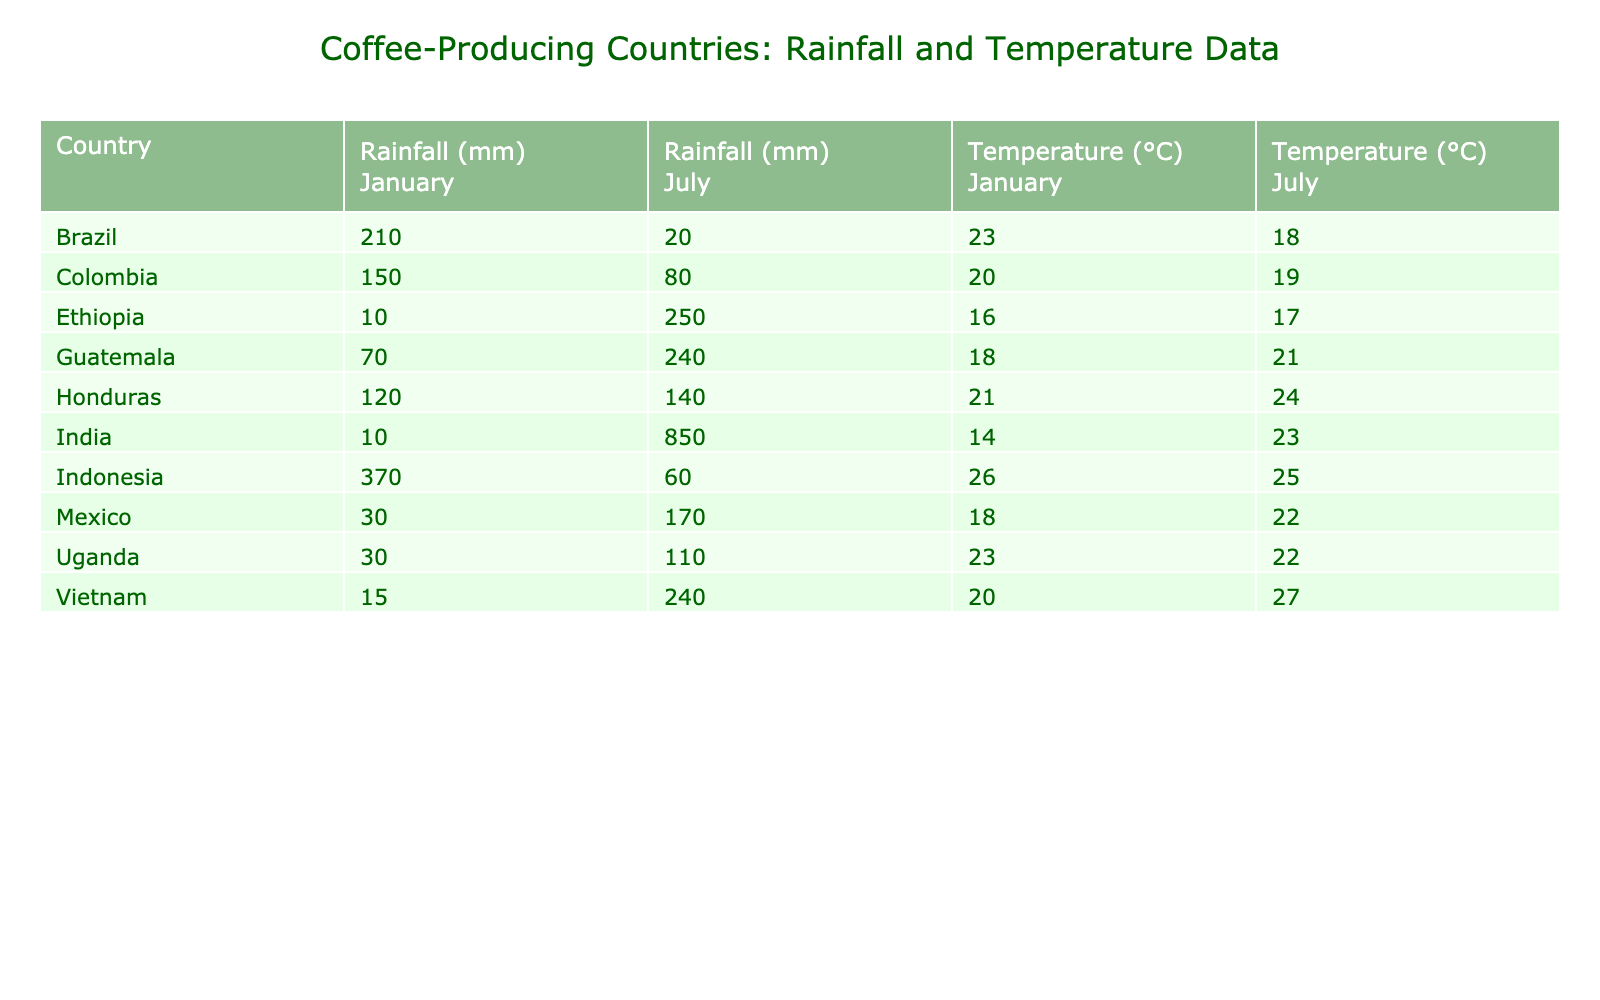What is the highest recorded rainfall in January among the countries listed? By looking at the January rainfall data, Indonesia has the highest value at 370 mm.
Answer: 370 mm Which country has the lowest temperature in July? The July temperature for Ethiopia is the lowest at 17 °C, compared to other countries listed.
Answer: 17 °C What is the total rainfall for Colombia in both January and July? The rainfall for Colombia is 150 mm in January and 80 mm in July, summing these gives 150 + 80 = 230 mm.
Answer: 230 mm Is the average temperature in January for all countries above 20 °C? The average temperature in January for the countries is (23 + 20 + 20 + 16 + 26 + 21 + 14 + 23 + 23 + 18 + 18) / 11 = 20.36 °C, which is above 20 °C.
Answer: Yes Which country experiences the most significant increase in rainfall from January to July? By comparing the rainfall data, India has a rainfall of 10 mm in January and 850 mm in July, a difference of 850 - 10 = 840 mm, which is the greatest increase.
Answer: India What is the average temperature in July for countries with rainfall over 100 mm in July? Countries above 100 mm in July are Vietnam (27 °C), Ethiopia (17 °C), Honduras (24 °C), and Guatemala (21 °C); the average is (27 + 17 + 24 + 21) / 4 = 22.25 °C.
Answer: 22.25 °C Which country has the highest temperature in January? In January, the highest temperature is noted for Brazil at 23 °C, which is higher than any other country listed.
Answer: 23 °C How does the July rainfall in Uganda compare to that of Mexico? Uganda has a July rainfall of 110 mm, while Mexico has 170 mm. Since 170 mm is greater, Mexico has higher rainfall in July.
Answer: Mexico has higher rainfall What is the difference in rainfall between Indonesia and Ethiopia in July? Indonesia has 60 mm in July and Ethiopia has 250 mm, so the difference is 250 - 60 = 190 mm.
Answer: 190 mm Is the July temperature in Colombia higher than that in Honduras? Colombia’s July temperature is 19 °C and Honduras's is 24 °C, thus Honduras has a higher temperature in July.
Answer: No 